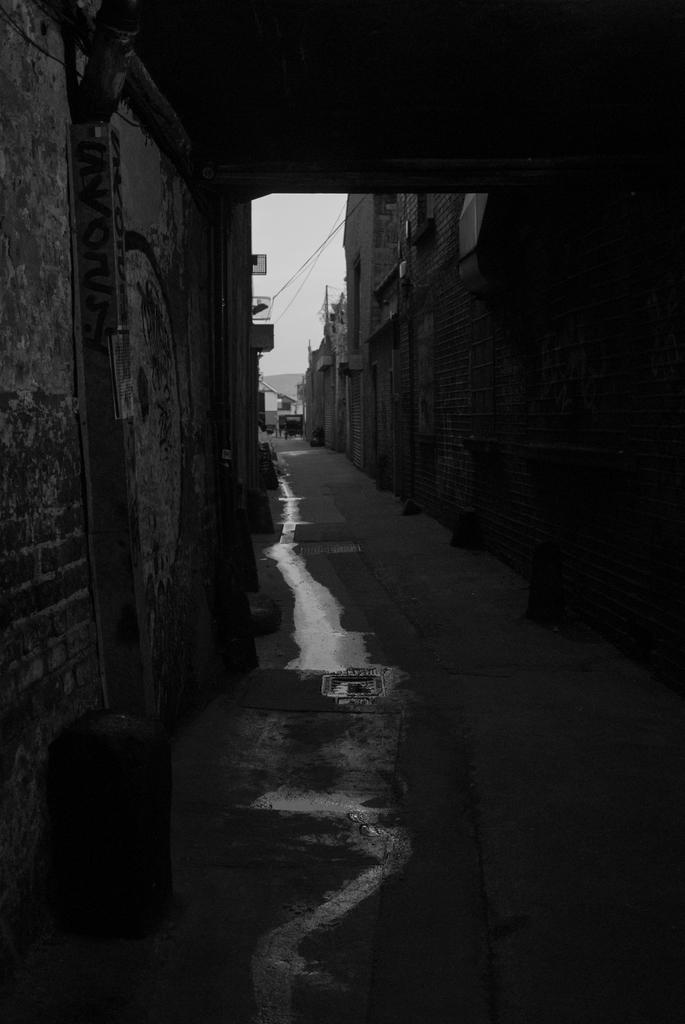What type of picture is in the image? The image contains a black and white picture of a group of buildings. What else can be seen in the image besides the buildings? There are sign boards and cables visible in the image. What object is on the ground in the image? There is a trash can on the ground in the image. What is visible in the background of the image? The sky is visible in the background of the image. What type of celery can be seen growing near the trash can in the image? There is no celery present in the image; it is a picture of a group of buildings with sign boards, cables, and a trash can on the ground. 